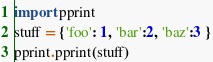<code> <loc_0><loc_0><loc_500><loc_500><_Python_>import pprint
stuff = {'foo': 1, 'bar':2, 'baz':3 }
pprint.pprint(stuff)
</code> 